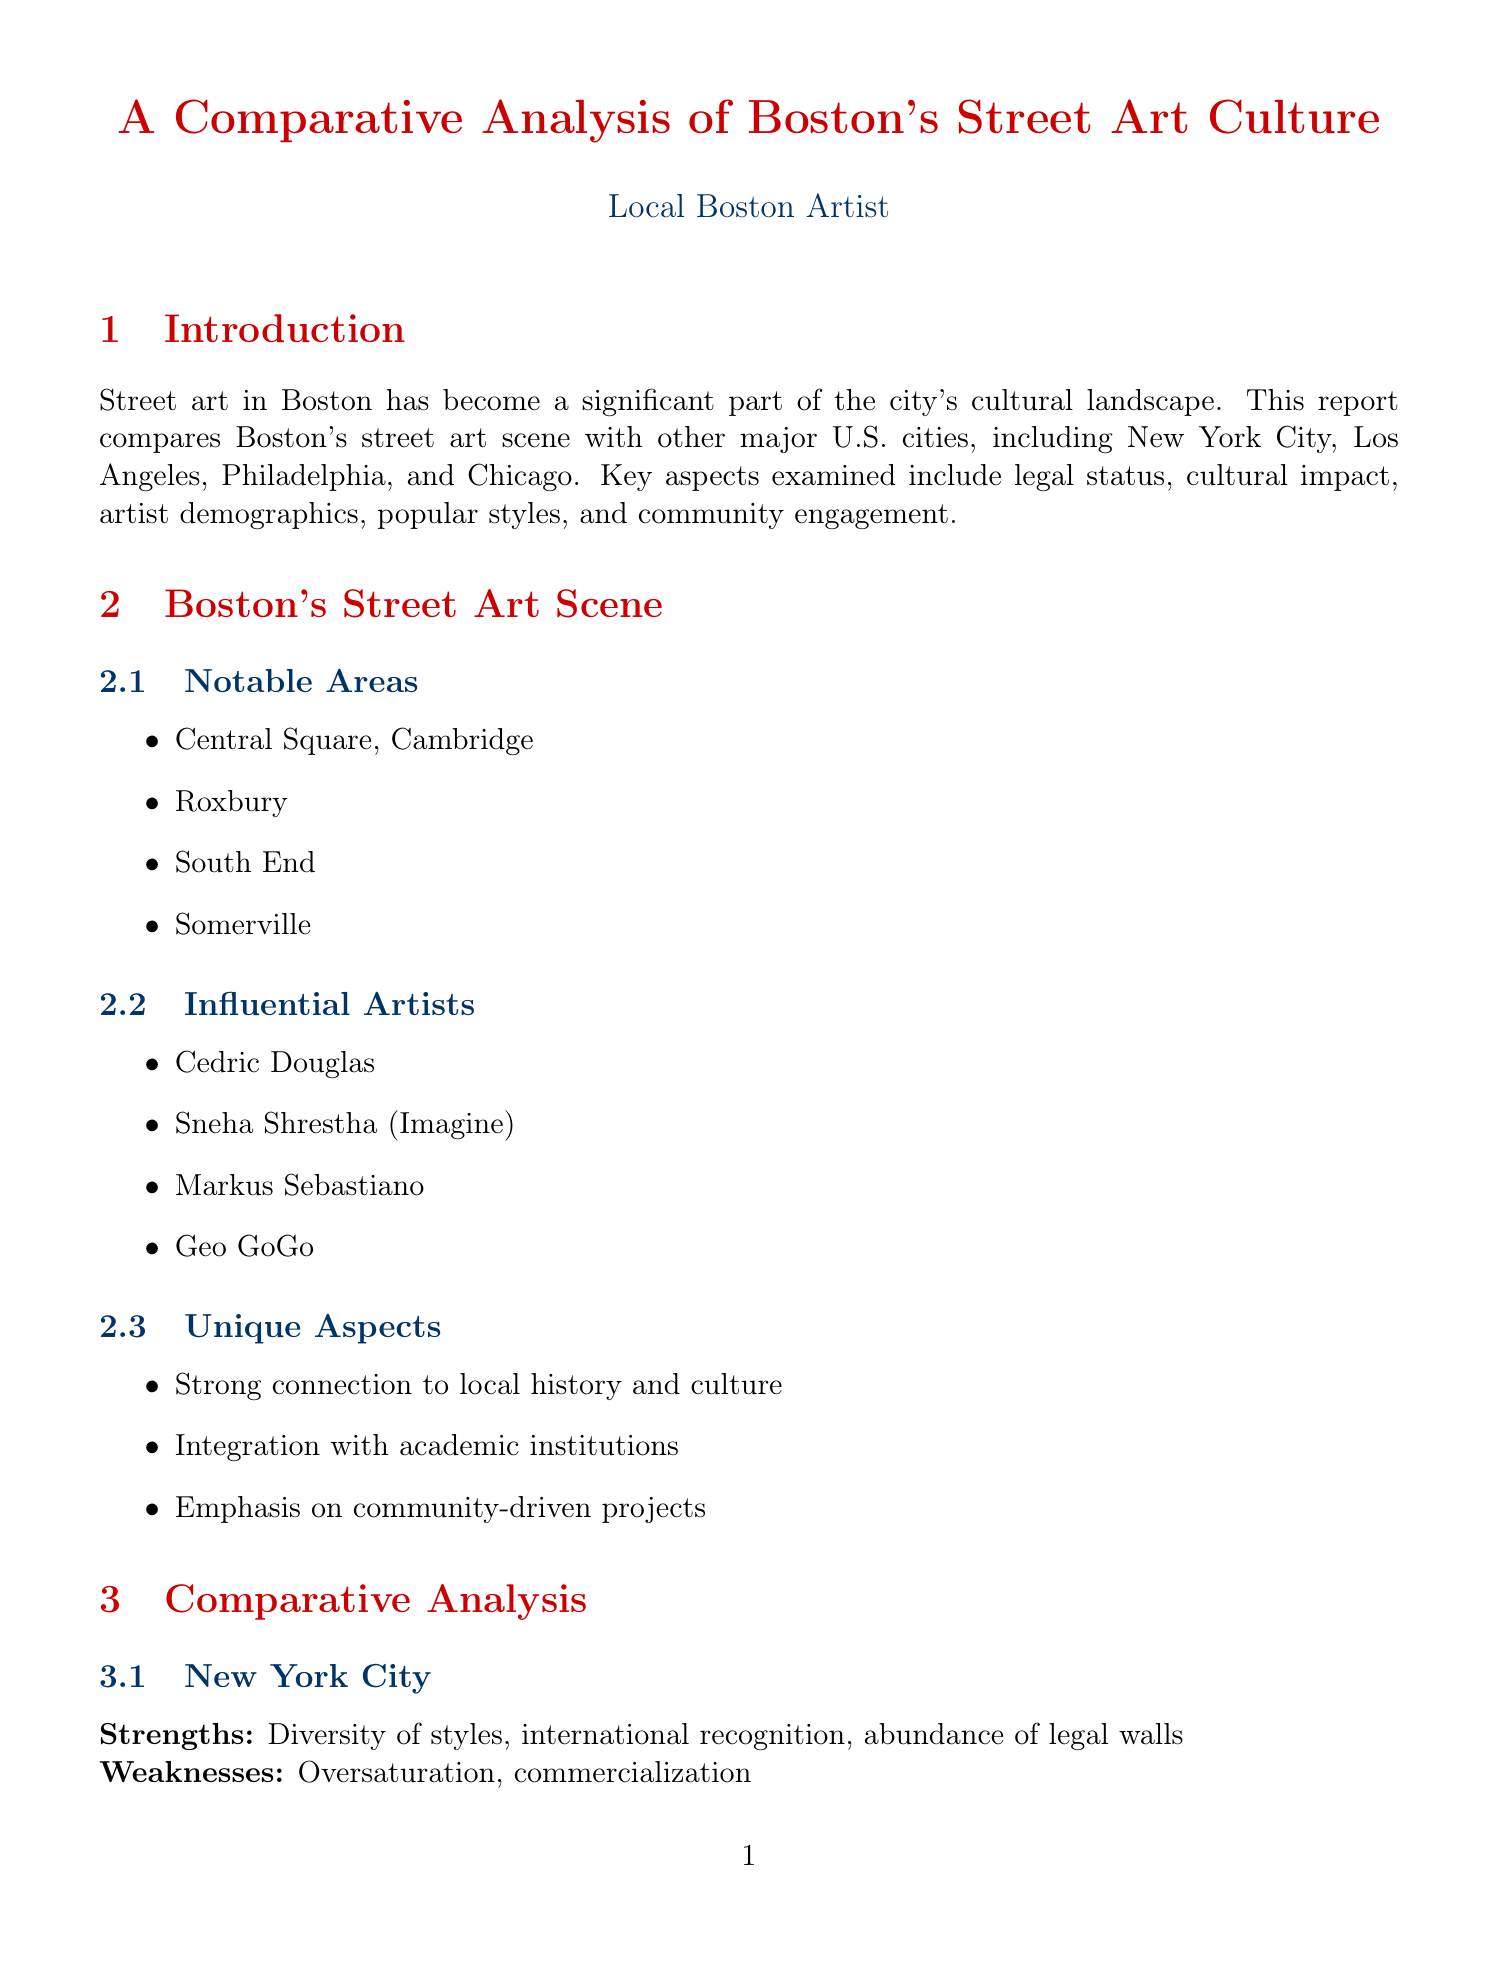What are the notable areas for street art in Boston? The notable areas for street art in Boston include Central Square, Cambridge, Roxbury, South End, and Somerville.
Answer: Central Square, Cambridge; Roxbury; South End; Somerville Who is an influential street artist mentioned in the report? One of the influential artists mentioned in the report is Cedric Douglas.
Answer: Cedric Douglas What is a legal framework area for growth in Boston? One of the legal framework areas for growth is the expansion of designated legal walls and spaces.
Answer: Expansion of designated legal walls and spaces What is the historical context of Boston's street art? The historical context highlights the integration of colonial and revolutionary themes.
Answer: Integration of colonial and revolutionary themes What strength is noted for New York City in street art? New York City's strength includes diversity of styles.
Answer: Diversity of styles What emerging trend is identified in the future outlook for street art? An emerging trend identified is eco-friendly and sustainable materials.
Answer: Eco-friendly and sustainable materials What unique aspect connects Boston's street art to local culture? Boston's street art has a strong connection to local history and culture.
Answer: Strong connection to local history and culture How many influential artists are listed for Boston? There are four influential artists listed for Boston.
Answer: Four What is a potential challenge in the future outlook for street art? A potential challenge is balancing preservation and evolution of street art.
Answer: Balancing preservation and evolution of street art 